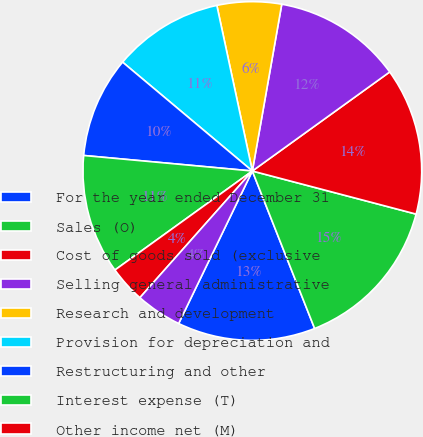<chart> <loc_0><loc_0><loc_500><loc_500><pie_chart><fcel>For the year ended December 31<fcel>Sales (O)<fcel>Cost of goods sold (exclusive<fcel>Selling general administrative<fcel>Research and development<fcel>Provision for depreciation and<fcel>Restructuring and other<fcel>Interest expense (T)<fcel>Other income net (M)<fcel>Loss from continuing<nl><fcel>13.16%<fcel>14.91%<fcel>14.04%<fcel>12.28%<fcel>6.14%<fcel>10.53%<fcel>9.65%<fcel>11.4%<fcel>3.51%<fcel>4.39%<nl></chart> 